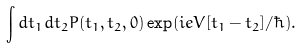Convert formula to latex. <formula><loc_0><loc_0><loc_500><loc_500>\int d t _ { 1 } d t _ { 2 } P ( t _ { 1 } , t _ { 2 } , 0 ) \exp ( i e V [ t _ { 1 } - t _ { 2 } ] / \hbar { ) } .</formula> 